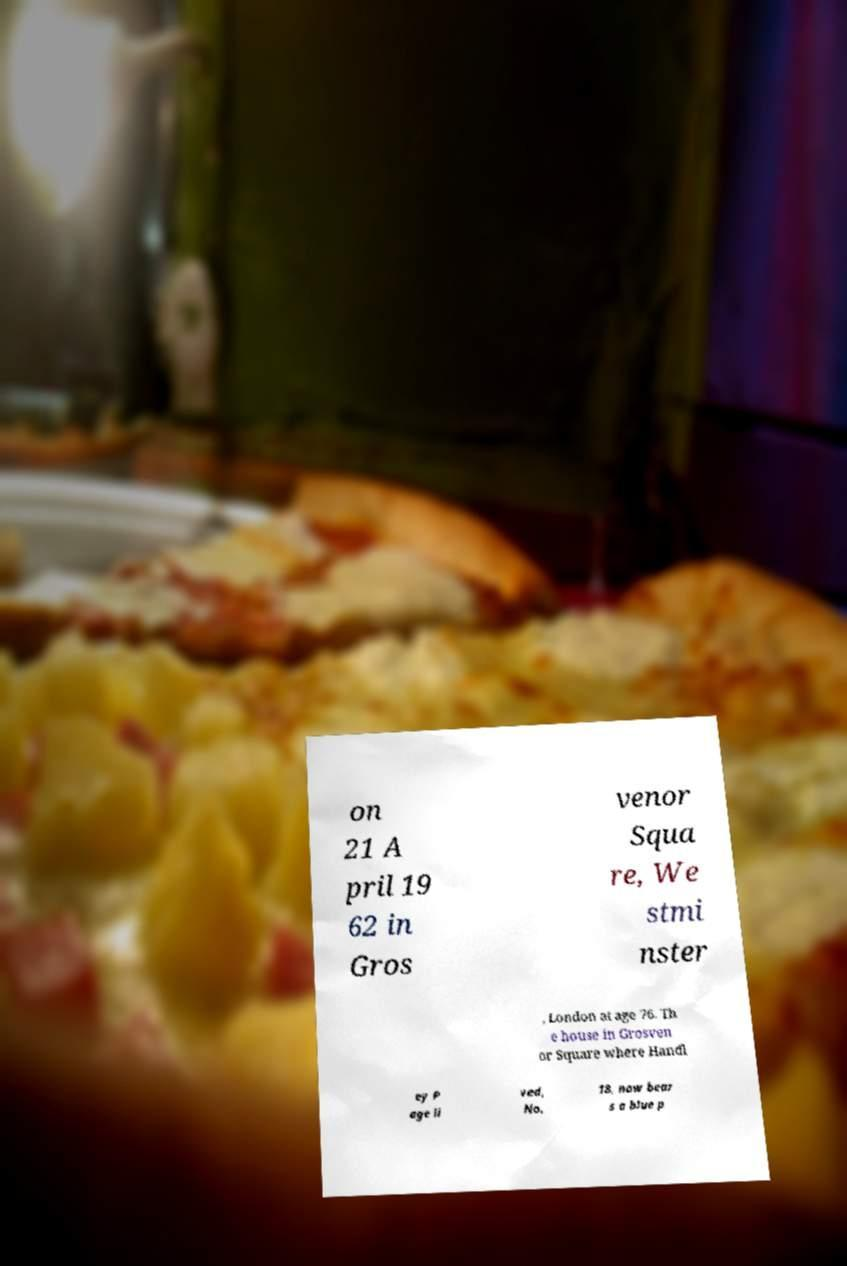Can you accurately transcribe the text from the provided image for me? on 21 A pril 19 62 in Gros venor Squa re, We stmi nster , London at age 76. Th e house in Grosven or Square where Handl ey P age li ved, No. 18, now bear s a blue p 